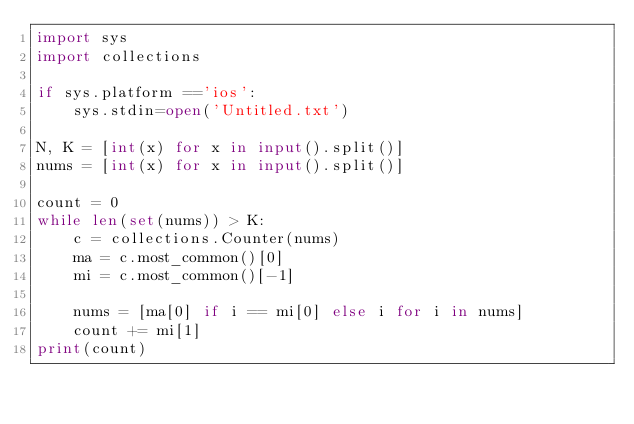<code> <loc_0><loc_0><loc_500><loc_500><_Python_>import sys
import collections

if sys.platform =='ios':
	sys.stdin=open('Untitled.txt')

N, K = [int(x) for x in input().split()]
nums = [int(x) for x in input().split()]

count =	0
while len(set(nums)) > K:
	c = collections.Counter(nums)
	ma = c.most_common()[0]
	mi = c.most_common()[-1]

	nums = [ma[0] if i == mi[0] else i for i in nums]
	count += mi[1]
print(count)</code> 